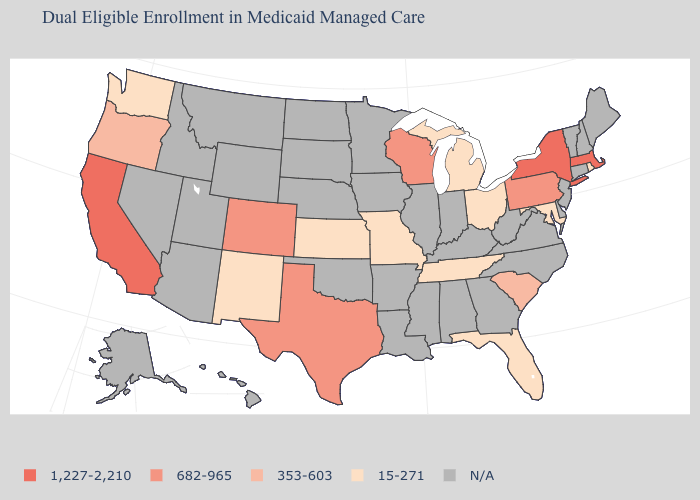Does Wisconsin have the lowest value in the MidWest?
Quick response, please. No. Does the map have missing data?
Keep it brief. Yes. What is the value of Nevada?
Concise answer only. N/A. What is the value of Virginia?
Quick response, please. N/A. Does Ohio have the lowest value in the USA?
Be succinct. Yes. How many symbols are there in the legend?
Give a very brief answer. 5. How many symbols are there in the legend?
Keep it brief. 5. Is the legend a continuous bar?
Keep it brief. No. What is the highest value in the USA?
Write a very short answer. 1,227-2,210. How many symbols are there in the legend?
Answer briefly. 5. Which states have the lowest value in the USA?
Concise answer only. Florida, Kansas, Maryland, Michigan, Missouri, New Mexico, Ohio, Rhode Island, Tennessee, Washington. What is the value of Alabama?
Short answer required. N/A. Name the states that have a value in the range 1,227-2,210?
Give a very brief answer. California, Massachusetts, New York. Name the states that have a value in the range 15-271?
Write a very short answer. Florida, Kansas, Maryland, Michigan, Missouri, New Mexico, Ohio, Rhode Island, Tennessee, Washington. 